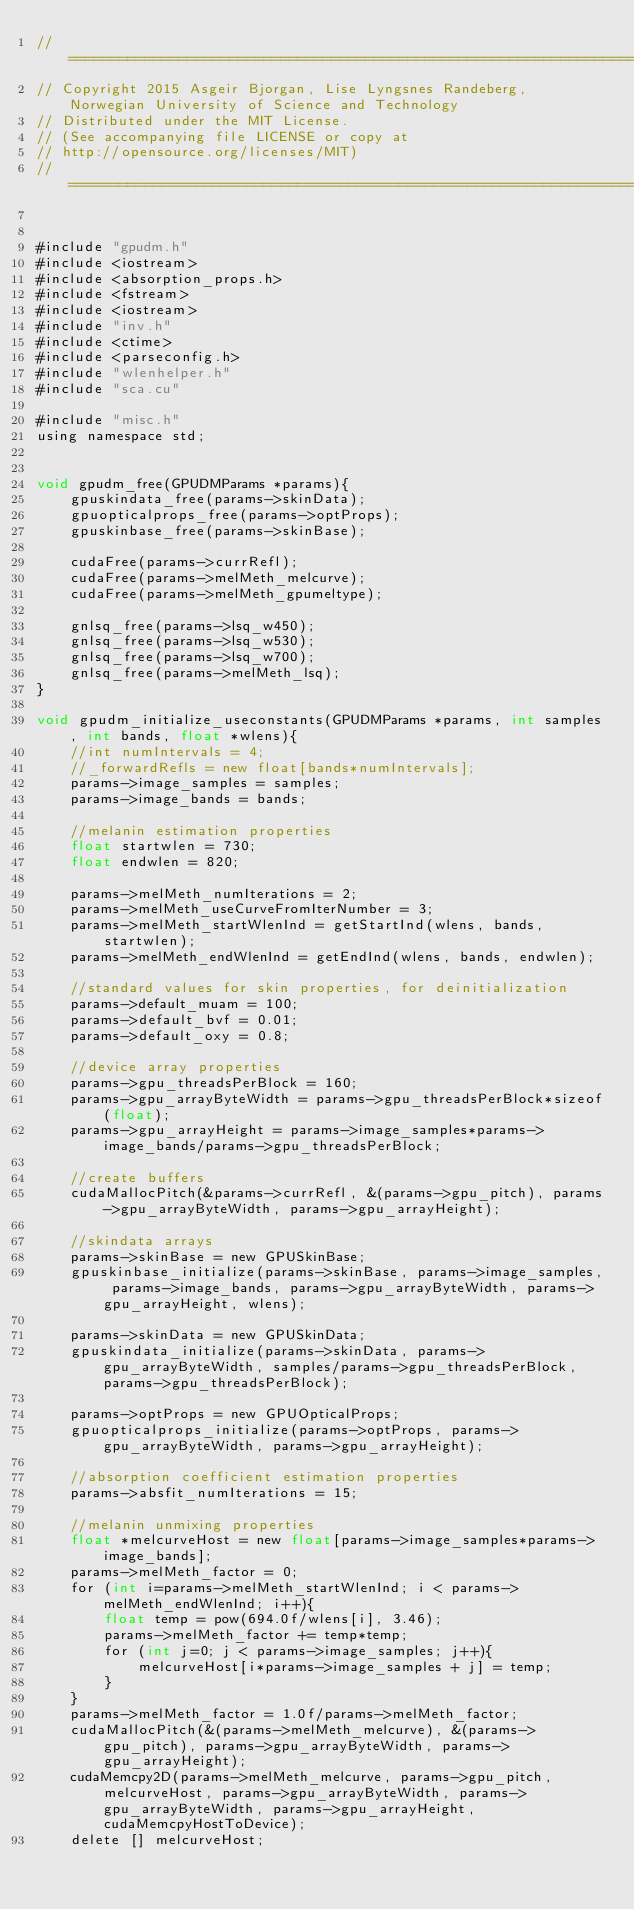Convert code to text. <code><loc_0><loc_0><loc_500><loc_500><_Cuda_>//=======================================================================================================
// Copyright 2015 Asgeir Bjorgan, Lise Lyngsnes Randeberg, Norwegian University of Science and Technology
// Distributed under the MIT License.
// (See accompanying file LICENSE or copy at
// http://opensource.org/licenses/MIT)
//=======================================================================================================


#include "gpudm.h"
#include <iostream>
#include <absorption_props.h>
#include <fstream>
#include <iostream>
#include "inv.h"
#include <ctime>
#include <parseconfig.h>
#include "wlenhelper.h"
#include "sca.cu"

#include "misc.h"
using namespace std;


void gpudm_free(GPUDMParams *params){
	gpuskindata_free(params->skinData);
	gpuopticalprops_free(params->optProps);
	gpuskinbase_free(params->skinBase);
	
	cudaFree(params->currRefl);
	cudaFree(params->melMeth_melcurve);
	cudaFree(params->melMeth_gpumeltype);

	gnlsq_free(params->lsq_w450);
	gnlsq_free(params->lsq_w530);
	gnlsq_free(params->lsq_w700);
	gnlsq_free(params->melMeth_lsq);
}

void gpudm_initialize_useconstants(GPUDMParams *params, int samples, int bands, float *wlens){
	//int numIntervals = 4;
	//_forwardRefls = new float[bands*numIntervals];
	params->image_samples = samples;
	params->image_bands = bands;

	//melanin estimation properties
	float startwlen = 730;
	float endwlen = 820;
	
	params->melMeth_numIterations = 2;
	params->melMeth_useCurveFromIterNumber = 3;
	params->melMeth_startWlenInd = getStartInd(wlens, bands, startwlen);
	params->melMeth_endWlenInd = getEndInd(wlens, bands, endwlen);
	
	//standard values for skin properties, for deinitialization
	params->default_muam = 100;
	params->default_bvf = 0.01;
	params->default_oxy = 0.8;

	//device array properties
	params->gpu_threadsPerBlock = 160;
	params->gpu_arrayByteWidth = params->gpu_threadsPerBlock*sizeof(float);
	params->gpu_arrayHeight = params->image_samples*params->image_bands/params->gpu_threadsPerBlock;

	//create buffers
	cudaMallocPitch(&params->currRefl, &(params->gpu_pitch), params->gpu_arrayByteWidth, params->gpu_arrayHeight);

	//skindata arrays
	params->skinBase = new GPUSkinBase;
	gpuskinbase_initialize(params->skinBase, params->image_samples, params->image_bands, params->gpu_arrayByteWidth, params->gpu_arrayHeight, wlens);

	params->skinData = new GPUSkinData;
	gpuskindata_initialize(params->skinData, params->gpu_arrayByteWidth, samples/params->gpu_threadsPerBlock, params->gpu_threadsPerBlock);

	params->optProps = new GPUOpticalProps;
	gpuopticalprops_initialize(params->optProps, params->gpu_arrayByteWidth, params->gpu_arrayHeight);

	//absorption coefficient estimation properties
	params->absfit_numIterations = 15;
	
	//melanin unmixing properties
	float *melcurveHost = new float[params->image_samples*params->image_bands];
	params->melMeth_factor = 0;
	for (int i=params->melMeth_startWlenInd; i < params->melMeth_endWlenInd; i++){
		float temp = pow(694.0f/wlens[i], 3.46);
		params->melMeth_factor += temp*temp;
		for (int j=0; j < params->image_samples; j++){
			melcurveHost[i*params->image_samples + j] = temp;
		}
	}
	params->melMeth_factor = 1.0f/params->melMeth_factor;
	cudaMallocPitch(&(params->melMeth_melcurve), &(params->gpu_pitch), params->gpu_arrayByteWidth, params->gpu_arrayHeight);
	cudaMemcpy2D(params->melMeth_melcurve, params->gpu_pitch, melcurveHost, params->gpu_arrayByteWidth, params->gpu_arrayByteWidth, params->gpu_arrayHeight, cudaMemcpyHostToDevice);
	delete [] melcurveHost;

</code> 